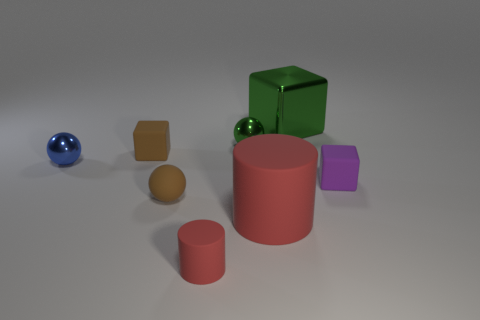What is the size of the other rubber cylinder that is the same color as the tiny rubber cylinder?
Make the answer very short. Large. Is there any other thing that is the same color as the large metal block?
Offer a very short reply. Yes. What shape is the metallic thing that is the same color as the big block?
Your answer should be very brief. Sphere. What shape is the purple rubber object that is the same size as the brown rubber cube?
Keep it short and to the point. Cube. Does the large block have the same color as the sphere behind the blue ball?
Offer a terse response. Yes. There is a tiny sphere that is right of the small red cylinder; how many blue shiny spheres are in front of it?
Your answer should be very brief. 1. There is a block that is in front of the green ball and right of the small rubber cylinder; what size is it?
Ensure brevity in your answer.  Small. Are there any yellow metallic cylinders that have the same size as the blue shiny sphere?
Offer a very short reply. No. Is the number of small objects behind the big cylinder greater than the number of tiny brown cubes that are to the right of the small purple rubber cube?
Provide a short and direct response. Yes. Are the green cube and the small ball behind the blue object made of the same material?
Provide a succinct answer. Yes. 